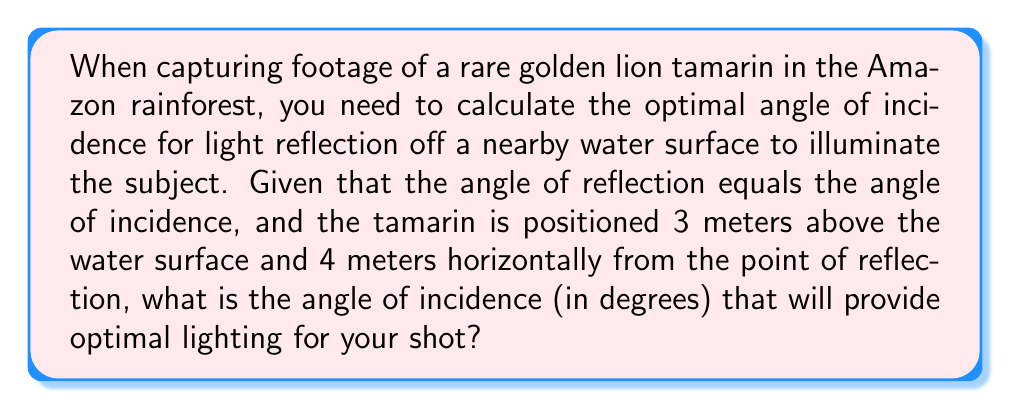Help me with this question. Let's approach this step-by-step:

1) First, let's visualize the scenario:

[asy]
import geometry;

pair A = (0,0);  // Point of reflection on water
pair B = (4,3);  // Position of the tamarin
pair C = (4,0);  // Point directly below the tamarin

draw(A--B--C--A);
draw((-1,0)--(5,0), arrow=Arrow(TeXHead));
draw((0,-0.5)--(0,3.5), arrow=Arrow(TeXHead));

label("Water surface", (2,-0.3));
label("3m", (4.3,1.5));
label("4m", (2,-0.3));
label("θ", (0.3,0.3));
label("θ", (3.7,2.7));

dot("A", A, SW);
dot("B", B, NE);
dot("C", C, SE);
[/asy]

2) We can see that this forms a right-angled triangle ABC, where:
   - A is the point of reflection on the water surface
   - B is the position of the tamarin
   - C is the point directly below the tamarin on the water surface

3) We need to find the angle θ, which is both the angle of incidence and the angle of reflection.

4) In the right-angled triangle ABC:
   - The adjacent side (AC) = 4 meters
   - The opposite side (BC) = 3 meters

5) We can use the trigonometric function tangent to find θ:

   $$\tan(\theta) = \frac{\text{opposite}}{\text{adjacent}} = \frac{3}{4}$$

6) To find θ, we need to take the inverse tangent (arctangent):

   $$\theta = \arctan(\frac{3}{4})$$

7) Using a calculator or computer, we can compute this value:

   $$\theta \approx 36.87\text{°}$$

Therefore, the optimal angle of incidence for light reflection is approximately 36.87°.
Answer: $36.87\text{°}$ 